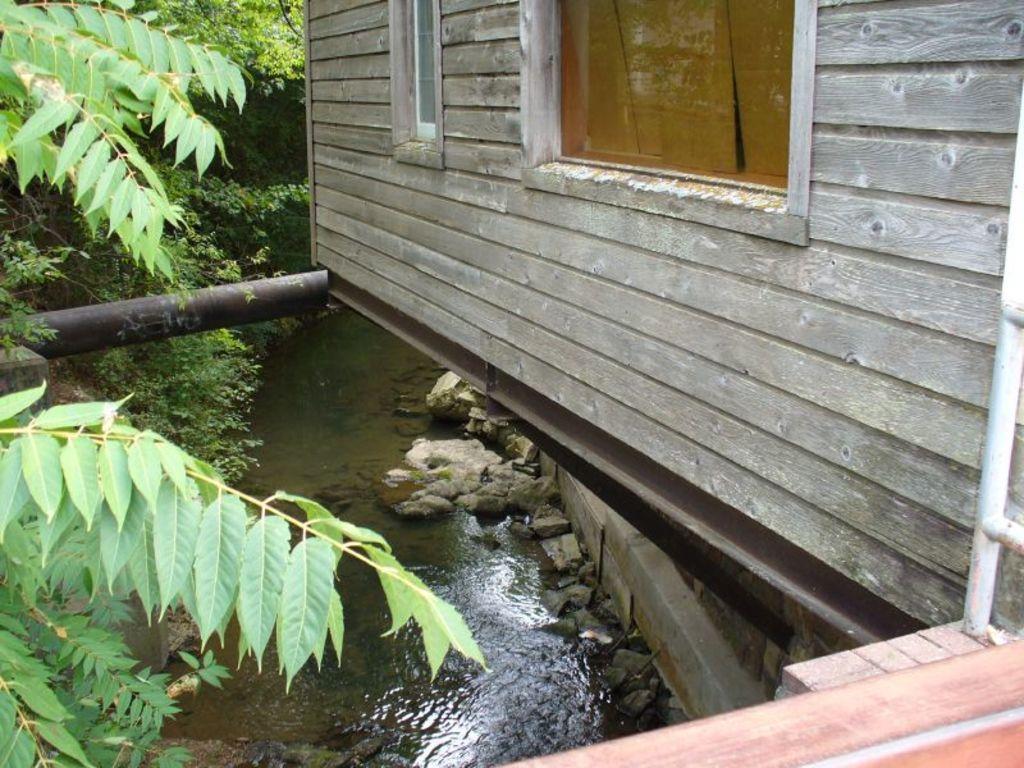In one or two sentences, can you explain what this image depicts? This is the backside view of the house where we can see a window. At the background there are trees, water. 